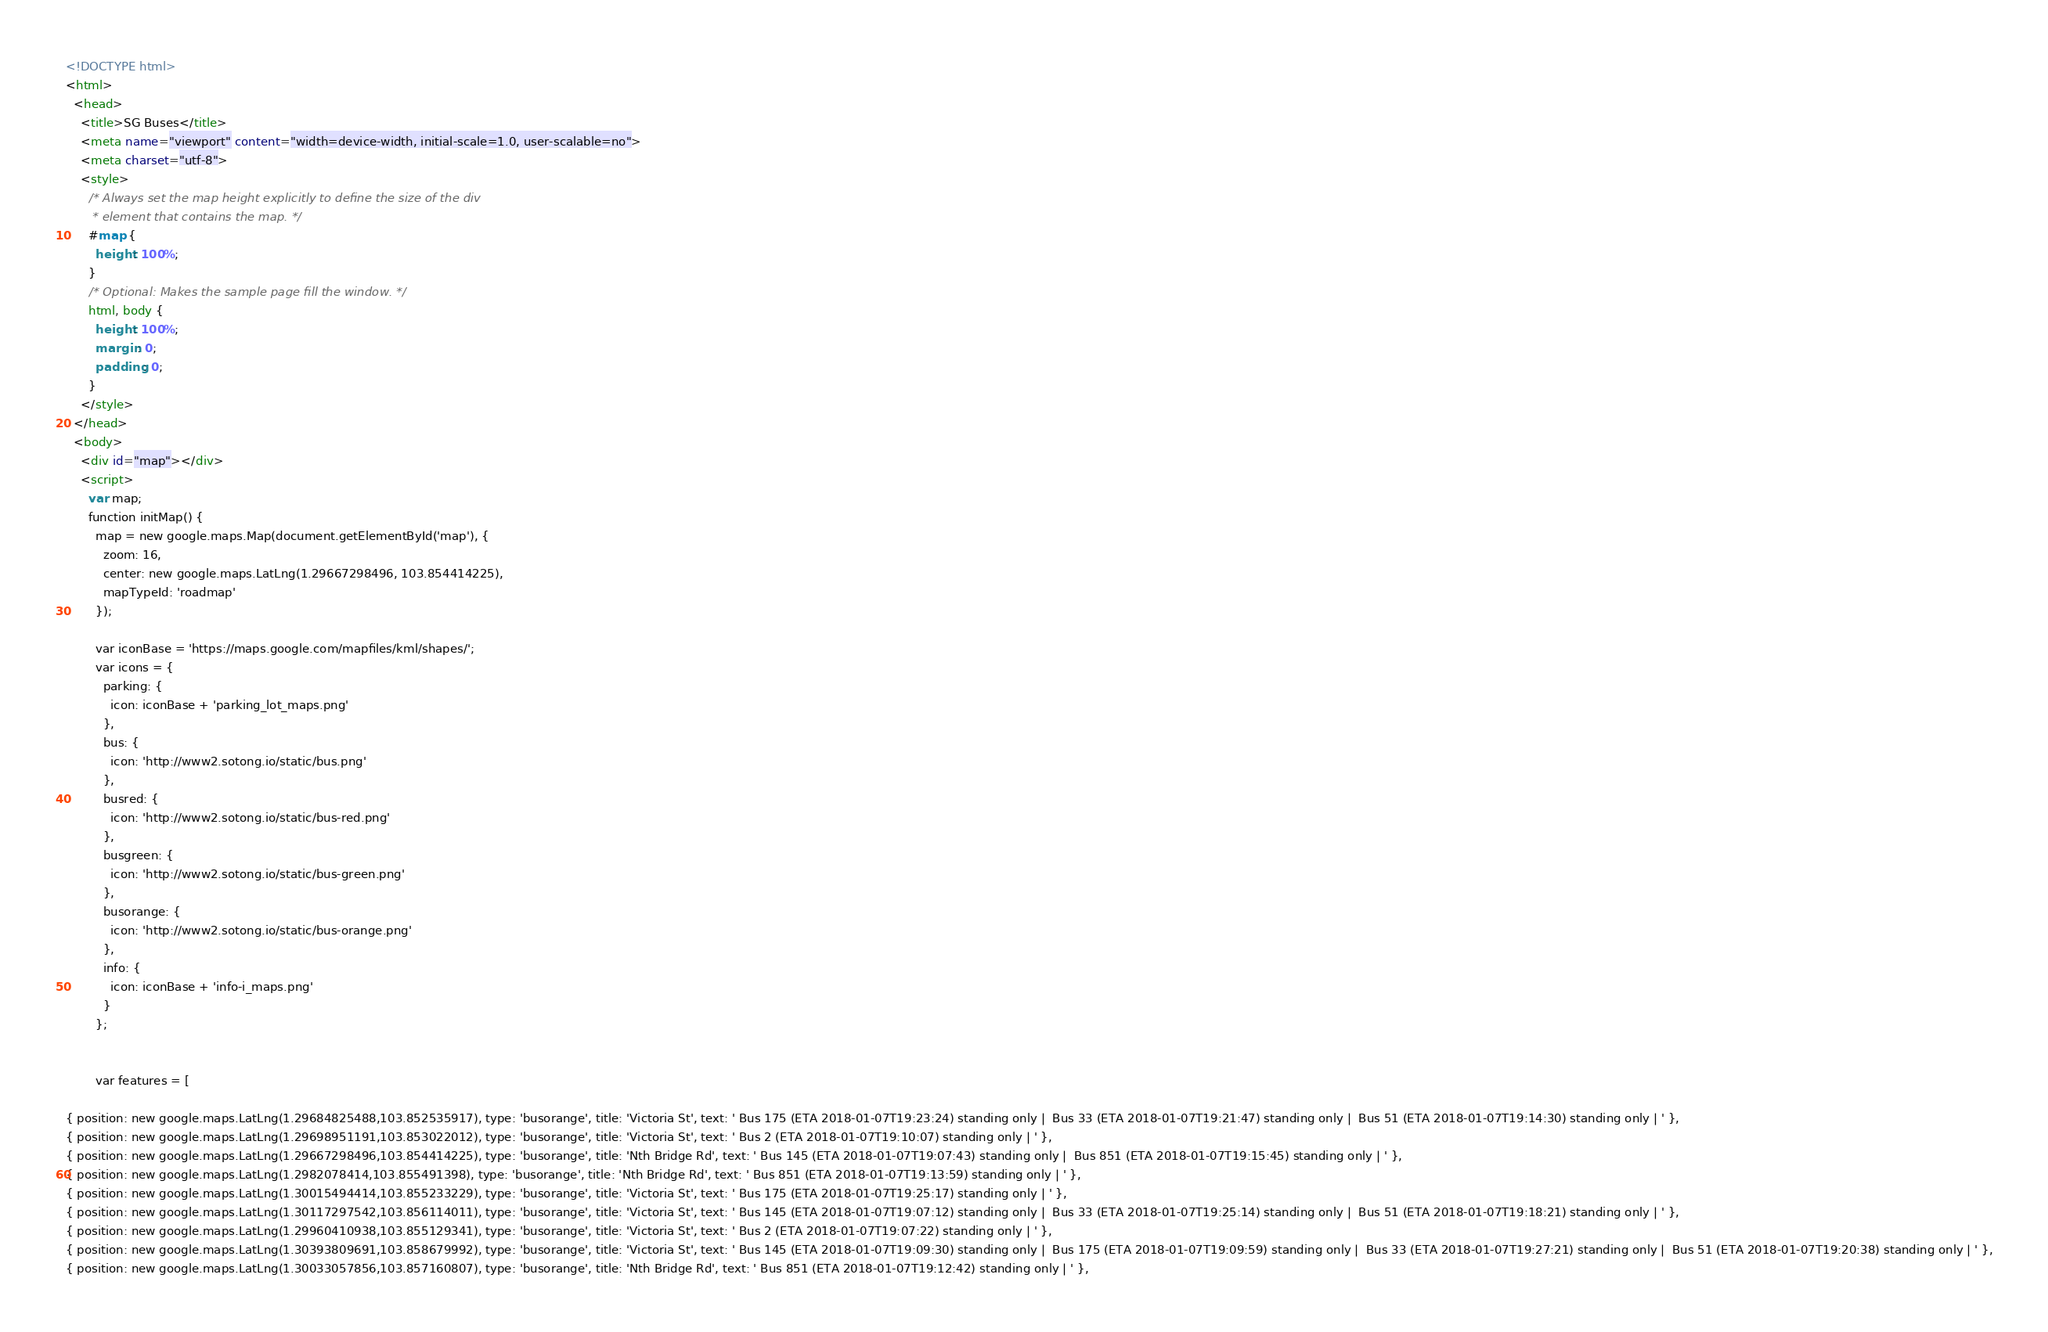Convert code to text. <code><loc_0><loc_0><loc_500><loc_500><_HTML_><!DOCTYPE html>
<html>
  <head>
    <title>SG Buses</title>
    <meta name="viewport" content="width=device-width, initial-scale=1.0, user-scalable=no">
    <meta charset="utf-8">
    <style>
      /* Always set the map height explicitly to define the size of the div
       * element that contains the map. */
      #map {
        height: 100%;
      }
      /* Optional: Makes the sample page fill the window. */
      html, body {
        height: 100%;
        margin: 0;
        padding: 0;
      }
    </style>
  </head>
  <body>
    <div id="map"></div>
    <script>
      var map;
      function initMap() {
        map = new google.maps.Map(document.getElementById('map'), {
          zoom: 16,
          center: new google.maps.LatLng(1.29667298496, 103.854414225),
          mapTypeId: 'roadmap'
        });

        var iconBase = 'https://maps.google.com/mapfiles/kml/shapes/';
        var icons = {
          parking: {
            icon: iconBase + 'parking_lot_maps.png'
          },
          bus: {
            icon: 'http://www2.sotong.io/static/bus.png'
          },
          busred: {
            icon: 'http://www2.sotong.io/static/bus-red.png'
          },
          busgreen: {
            icon: 'http://www2.sotong.io/static/bus-green.png'
          },
          busorange: {
            icon: 'http://www2.sotong.io/static/bus-orange.png'
          },
          info: {
            icon: iconBase + 'info-i_maps.png'
          }
        };


        var features = [

{ position: new google.maps.LatLng(1.29684825488,103.852535917), type: 'busorange', title: 'Victoria St', text: ' Bus 175 (ETA 2018-01-07T19:23:24) standing only |  Bus 33 (ETA 2018-01-07T19:21:47) standing only |  Bus 51 (ETA 2018-01-07T19:14:30) standing only | ' },
{ position: new google.maps.LatLng(1.29698951191,103.853022012), type: 'busorange', title: 'Victoria St', text: ' Bus 2 (ETA 2018-01-07T19:10:07) standing only | ' },
{ position: new google.maps.LatLng(1.29667298496,103.854414225), type: 'busorange', title: 'Nth Bridge Rd', text: ' Bus 145 (ETA 2018-01-07T19:07:43) standing only |  Bus 851 (ETA 2018-01-07T19:15:45) standing only | ' },
{ position: new google.maps.LatLng(1.2982078414,103.855491398), type: 'busorange', title: 'Nth Bridge Rd', text: ' Bus 851 (ETA 2018-01-07T19:13:59) standing only | ' },
{ position: new google.maps.LatLng(1.30015494414,103.855233229), type: 'busorange', title: 'Victoria St', text: ' Bus 175 (ETA 2018-01-07T19:25:17) standing only | ' },
{ position: new google.maps.LatLng(1.30117297542,103.856114011), type: 'busorange', title: 'Victoria St', text: ' Bus 145 (ETA 2018-01-07T19:07:12) standing only |  Bus 33 (ETA 2018-01-07T19:25:14) standing only |  Bus 51 (ETA 2018-01-07T19:18:21) standing only | ' },
{ position: new google.maps.LatLng(1.29960410938,103.855129341), type: 'busorange', title: 'Victoria St', text: ' Bus 2 (ETA 2018-01-07T19:07:22) standing only | ' },
{ position: new google.maps.LatLng(1.30393809691,103.858679992), type: 'busorange', title: 'Victoria St', text: ' Bus 145 (ETA 2018-01-07T19:09:30) standing only |  Bus 175 (ETA 2018-01-07T19:09:59) standing only |  Bus 33 (ETA 2018-01-07T19:27:21) standing only |  Bus 51 (ETA 2018-01-07T19:20:38) standing only | ' },
{ position: new google.maps.LatLng(1.30033057856,103.857160807), type: 'busorange', title: 'Nth Bridge Rd', text: ' Bus 851 (ETA 2018-01-07T19:12:42) standing only | ' },</code> 